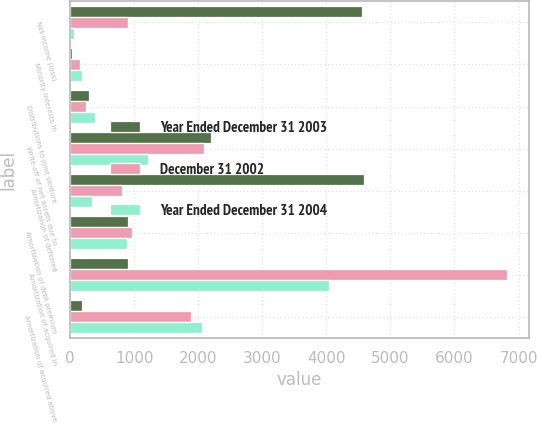Convert chart. <chart><loc_0><loc_0><loc_500><loc_500><stacked_bar_chart><ecel><fcel>Net income (loss)<fcel>Minority interests in<fcel>Distributions to joint venture<fcel>Write-off of net assets due to<fcel>Amortization of deferred<fcel>Amortization of debt premium<fcel>Amortization of acquired in<fcel>Amortization of acquired above<nl><fcel>Year Ended December 31 2003<fcel>4557<fcel>24<fcel>288<fcel>2204<fcel>4590<fcel>903<fcel>896<fcel>190<nl><fcel>December 31 2002<fcel>896<fcel>149<fcel>240<fcel>2094<fcel>816<fcel>970<fcel>6815<fcel>1892<nl><fcel>Year Ended December 31 2004<fcel>61<fcel>190<fcel>395<fcel>1210<fcel>341<fcel>889<fcel>4038<fcel>2051<nl></chart> 